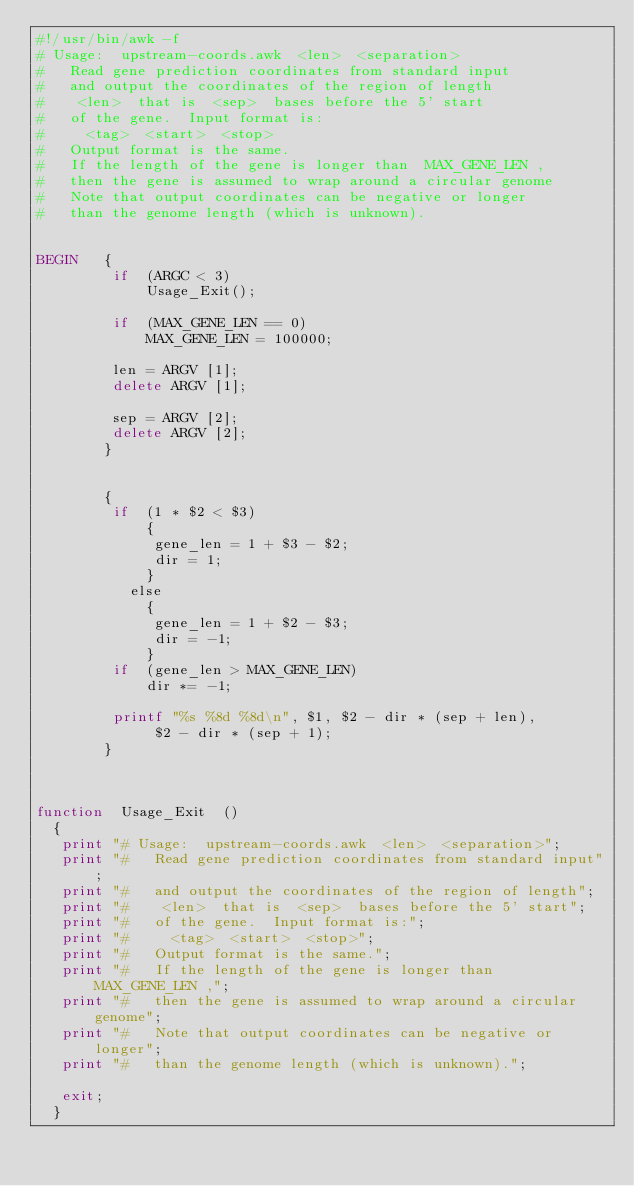Convert code to text. <code><loc_0><loc_0><loc_500><loc_500><_Awk_>#!/usr/bin/awk -f
# Usage:  upstream-coords.awk  <len>  <separation>
#   Read gene prediction coordinates from standard input
#   and output the coordinates of the region of length
#    <len>  that is  <sep>  bases before the 5' start
#   of the gene.  Input format is:
#     <tag>  <start>  <stop>
#   Output format is the same.
#   If the length of the gene is longer than  MAX_GENE_LEN ,
#   then the gene is assumed to wrap around a circular genome
#   Note that output coordinates can be negative or longer
#   than the genome length (which is unknown).


BEGIN   {
         if  (ARGC < 3)
             Usage_Exit();

         if  (MAX_GENE_LEN == 0)
             MAX_GENE_LEN = 100000;

         len = ARGV [1];
         delete ARGV [1];

         sep = ARGV [2];
         delete ARGV [2];
        }


        {
         if  (1 * $2 < $3)
             {
              gene_len = 1 + $3 - $2;
              dir = 1;
             }
           else
             {
              gene_len = 1 + $2 - $3;
              dir = -1;
             }
         if  (gene_len > MAX_GENE_LEN)
             dir *= -1;

         printf "%s %8d %8d\n", $1, $2 - dir * (sep + len),
              $2 - dir * (sep + 1);
        }



function  Usage_Exit  ()
  {
   print "# Usage:  upstream-coords.awk  <len>  <separation>";
   print "#   Read gene prediction coordinates from standard input";
   print "#   and output the coordinates of the region of length";
   print "#    <len>  that is  <sep>  bases before the 5' start";
   print "#   of the gene.  Input format is:";
   print "#     <tag>  <start>  <stop>";
   print "#   Output format is the same.";
   print "#   If the length of the gene is longer than  MAX_GENE_LEN ,";
   print "#   then the gene is assumed to wrap around a circular genome";
   print "#   Note that output coordinates can be negative or longer";
   print "#   than the genome length (which is unknown).";

   exit;
  }
</code> 